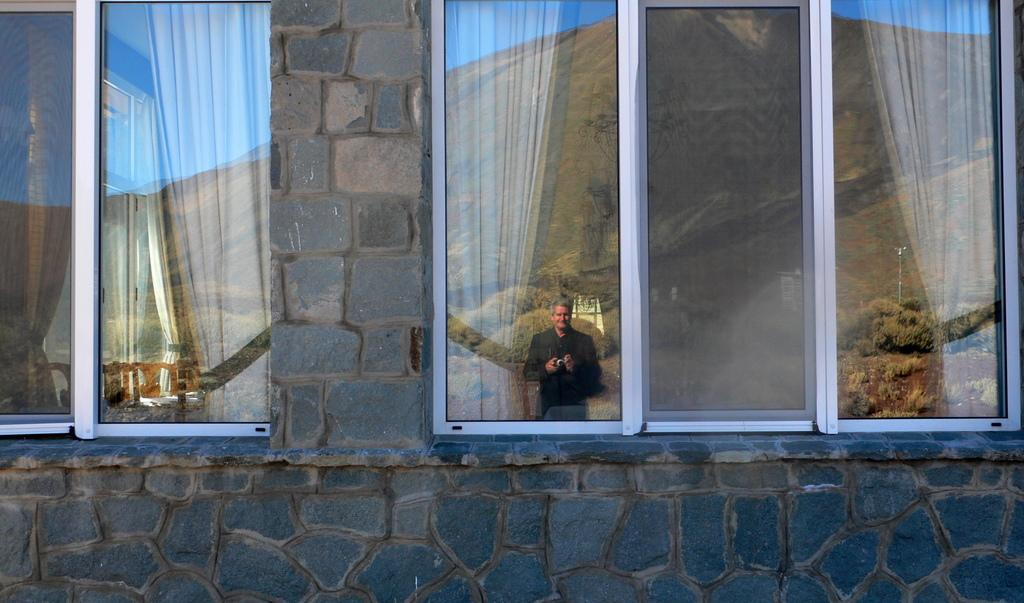What type of structure can be seen in the image? There is a wall in the image. What is present on the wall? There are glass windows in the image. What can be seen through the glass windows? Curtains are visible through the glass windows. Who is present in the image? There is a man standing in the image. What is the man holding? The man is holding a camera. What is visible behind the man? Trees are visible behind the man. What can be seen in the distance behind the trees? There is a hill in the background of the image. What is visible in the sky in the image? The sky is visible in the background of the image. What type of disease is the man suffering from in the image? There is no indication in the image that the man is suffering from any disease. What is the man arguing about with the trees in the image? There is no argument present in the image; the man is simply standing with trees visible behind him. 